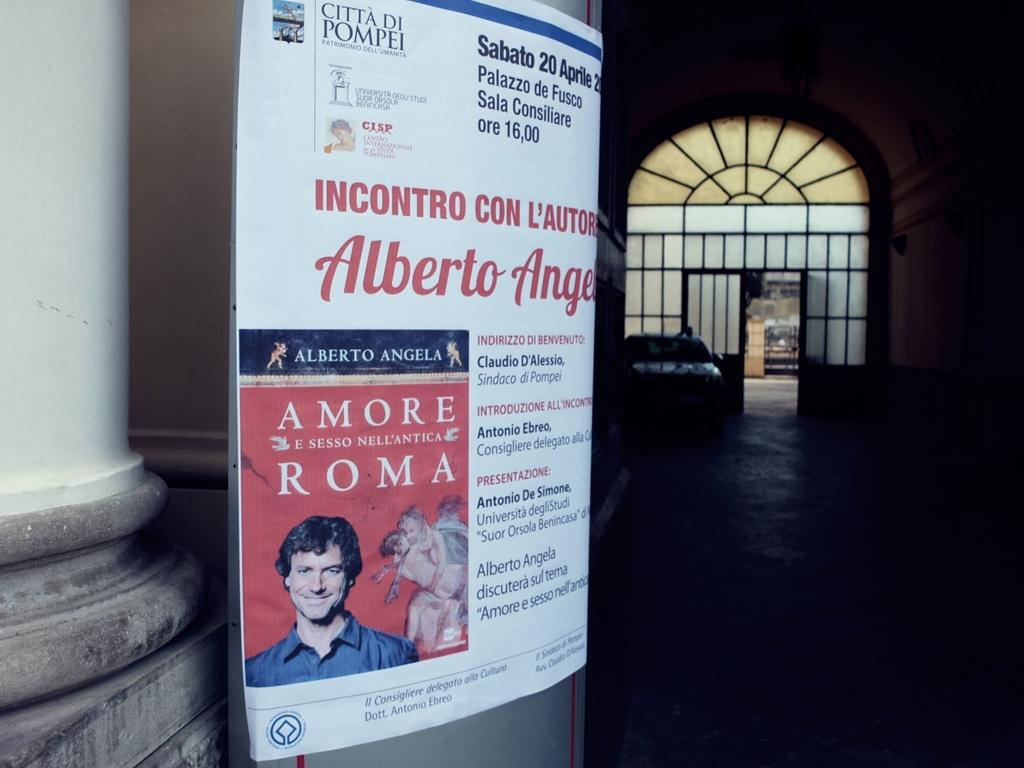What is one of the main structures visible in the image? There is a door in the image. What type of vehicle can be seen on the ground in the image? There is a car on the ground in the image. What type of signage is present in the image? There is a hoarding in the image. What architectural feature can be seen in the image? There is a pillar in the image. How many shoes are hanging from the door in the image? There are no shoes hanging from the door in the image. Is there a cobweb visible on the car in the image? There is no mention of a cobweb in the image, and it cannot be determined from the provided facts. 